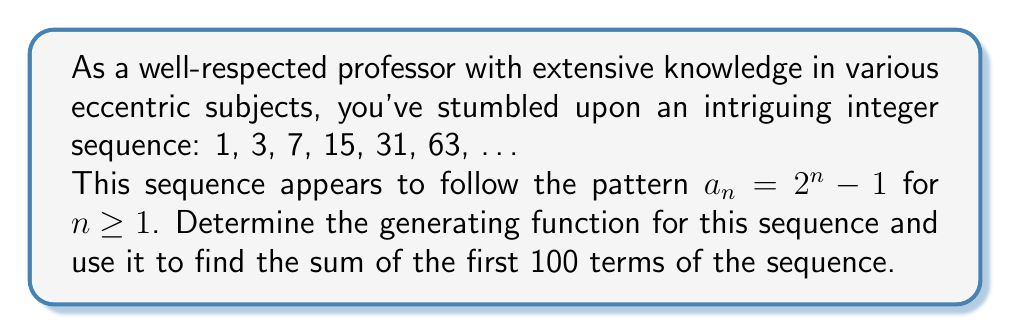Show me your answer to this math problem. Let's approach this step-by-step:

1) First, we need to find the generating function. Let's call it $G(x)$:

   $$G(x) = 1 + 3x + 7x^2 + 15x^3 + 31x^4 + 63x^5 + ...$$

2) We can rewrite this using the general term $a_n = 2^n - 1$:

   $$G(x) = (2^1 - 1)x^0 + (2^2 - 1)x^1 + (2^3 - 1)x^2 + (2^4 - 1)x^3 + ...$$

3) This can be split into two series:

   $$G(x) = (2x^0 + 2^2x^1 + 2^3x^2 + 2^4x^3 + ...) - (x^0 + x^1 + x^2 + x^3 + ...)$$

4) We recognize the second series as the geometric series with first term 1 and ratio x:

   $$\frac{1}{1-x}$$

5) The first series can be rewritten as:

   $$2(1 + 2x + (2x)^2 + (2x)^3 + ...)$$

   This is a geometric series with first term 2 and ratio 2x:

   $$\frac{2}{1-2x}$$

6) Therefore, our generating function is:

   $$G(x) = \frac{2}{1-2x} - \frac{1}{1-x}$$

7) To find the sum of the first 100 terms, we need to find $G'(x)$ and evaluate it at $x=1$:

   $$G'(x) = \frac{4}{(1-2x)^2} - \frac{1}{(1-x)^2}$$

8) The sum of the first 100 terms is:

   $$\sum_{n=1}^{100} a_n = \frac{G'(1)}{100!}$$

9) Evaluating $G'(1)$:

   $$G'(1) = \lim_{x \to 1} (\frac{4}{(1-2x)^2} - \frac{1}{(1-x)^2})$$

   This limit approaches infinity, which makes sense as our sequence grows exponentially.

10) However, we can find the sum directly using the formula for $a_n$:

    $$\sum_{n=1}^{100} a_n = \sum_{n=1}^{100} (2^n - 1) = \sum_{n=1}^{100} 2^n - \sum_{n=1}^{100} 1$$

11) Using the formula for the sum of a geometric series:

    $$\sum_{n=1}^{100} 2^n = 2(2^{100} - 1)$$

12) Therefore, the final sum is:

    $$2(2^{100} - 1) - 100 = 2^{101} - 2 - 100 = 2^{101} - 102$$
Answer: The generating function for the sequence is $G(x) = \frac{2}{1-2x} - \frac{1}{1-x}$, and the sum of the first 100 terms of the sequence is $2^{101} - 102$. 